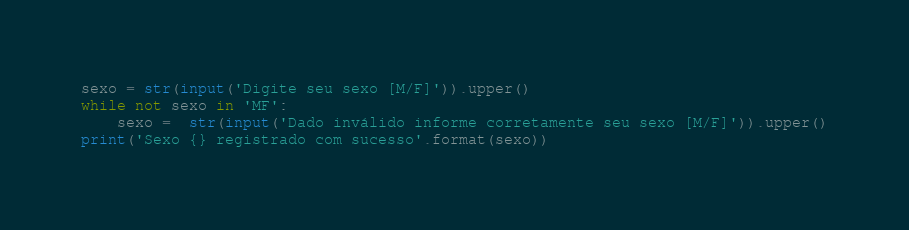Convert code to text. <code><loc_0><loc_0><loc_500><loc_500><_Python_>sexo = str(input('Digite seu sexo [M/F]')).upper()
while not sexo in 'MF':
    sexo =  str(input('Dado inválido informe corretamente seu sexo [M/F]')).upper()
print('Sexo {} registrado com sucesso'.format(sexo))</code> 